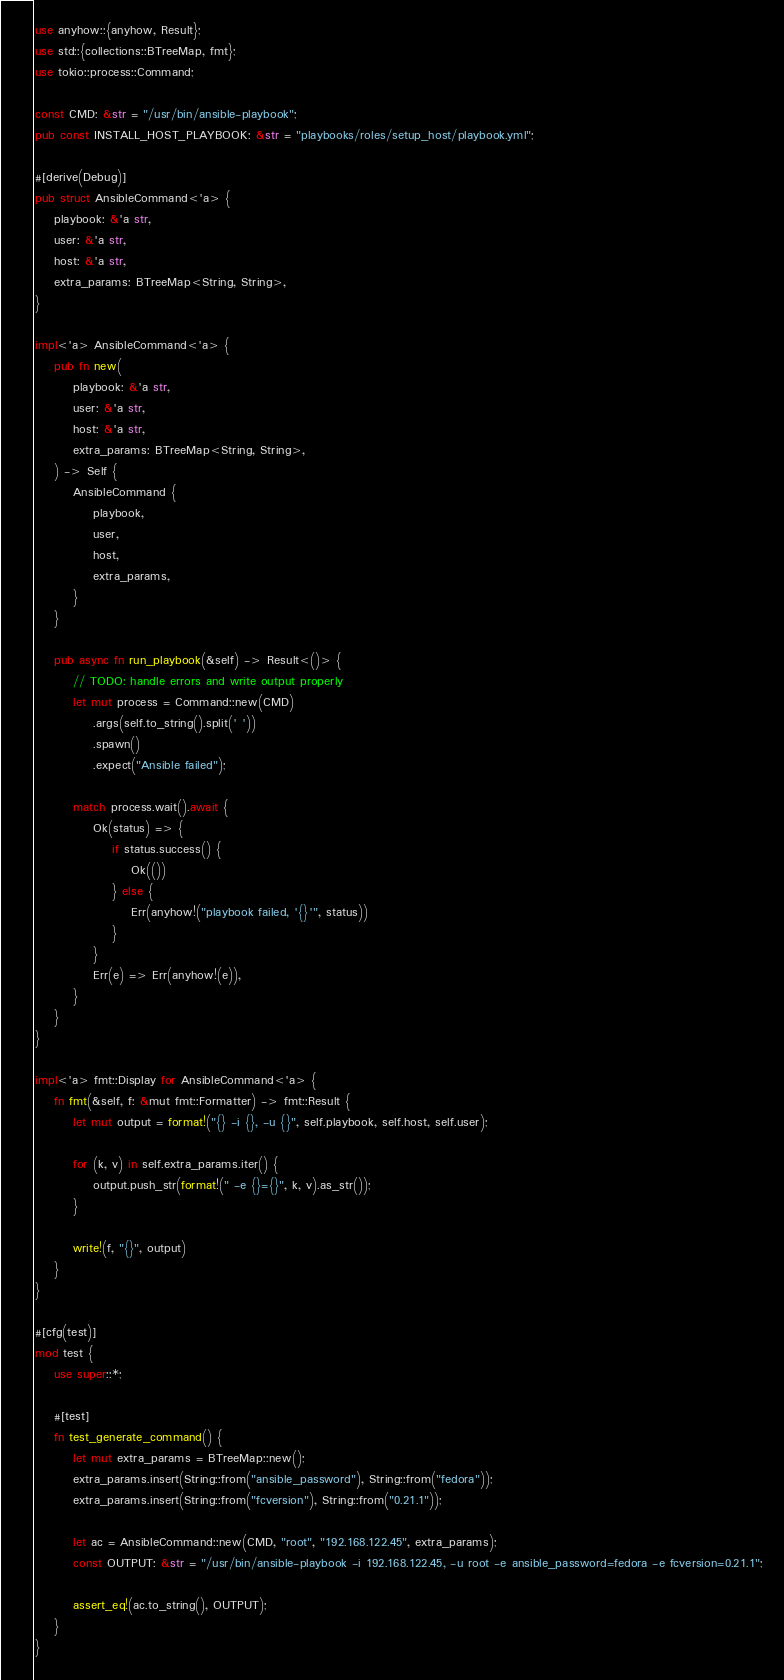Convert code to text. <code><loc_0><loc_0><loc_500><loc_500><_Rust_>use anyhow::{anyhow, Result};
use std::{collections::BTreeMap, fmt};
use tokio::process::Command;

const CMD: &str = "/usr/bin/ansible-playbook";
pub const INSTALL_HOST_PLAYBOOK: &str = "playbooks/roles/setup_host/playbook.yml";

#[derive(Debug)]
pub struct AnsibleCommand<'a> {
    playbook: &'a str,
    user: &'a str,
    host: &'a str,
    extra_params: BTreeMap<String, String>,
}

impl<'a> AnsibleCommand<'a> {
    pub fn new(
        playbook: &'a str,
        user: &'a str,
        host: &'a str,
        extra_params: BTreeMap<String, String>,
    ) -> Self {
        AnsibleCommand {
            playbook,
            user,
            host,
            extra_params,
        }
    }

    pub async fn run_playbook(&self) -> Result<()> {
        // TODO: handle errors and write output properly
        let mut process = Command::new(CMD)
            .args(self.to_string().split(' '))
            .spawn()
            .expect("Ansible failed");

        match process.wait().await {
            Ok(status) => {
                if status.success() {
                    Ok(())
                } else {
                    Err(anyhow!("playbook failed, '{}'", status))
                }
            }
            Err(e) => Err(anyhow!(e)),
        }
    }
}

impl<'a> fmt::Display for AnsibleCommand<'a> {
    fn fmt(&self, f: &mut fmt::Formatter) -> fmt::Result {
        let mut output = format!("{} -i {}, -u {}", self.playbook, self.host, self.user);

        for (k, v) in self.extra_params.iter() {
            output.push_str(format!(" -e {}={}", k, v).as_str());
        }

        write!(f, "{}", output)
    }
}

#[cfg(test)]
mod test {
    use super::*;

    #[test]
    fn test_generate_command() {
        let mut extra_params = BTreeMap::new();
        extra_params.insert(String::from("ansible_password"), String::from("fedora"));
        extra_params.insert(String::from("fcversion"), String::from("0.21.1"));

        let ac = AnsibleCommand::new(CMD, "root", "192.168.122.45", extra_params);
        const OUTPUT: &str = "/usr/bin/ansible-playbook -i 192.168.122.45, -u root -e ansible_password=fedora -e fcversion=0.21.1";

        assert_eq!(ac.to_string(), OUTPUT);
    }
}
</code> 